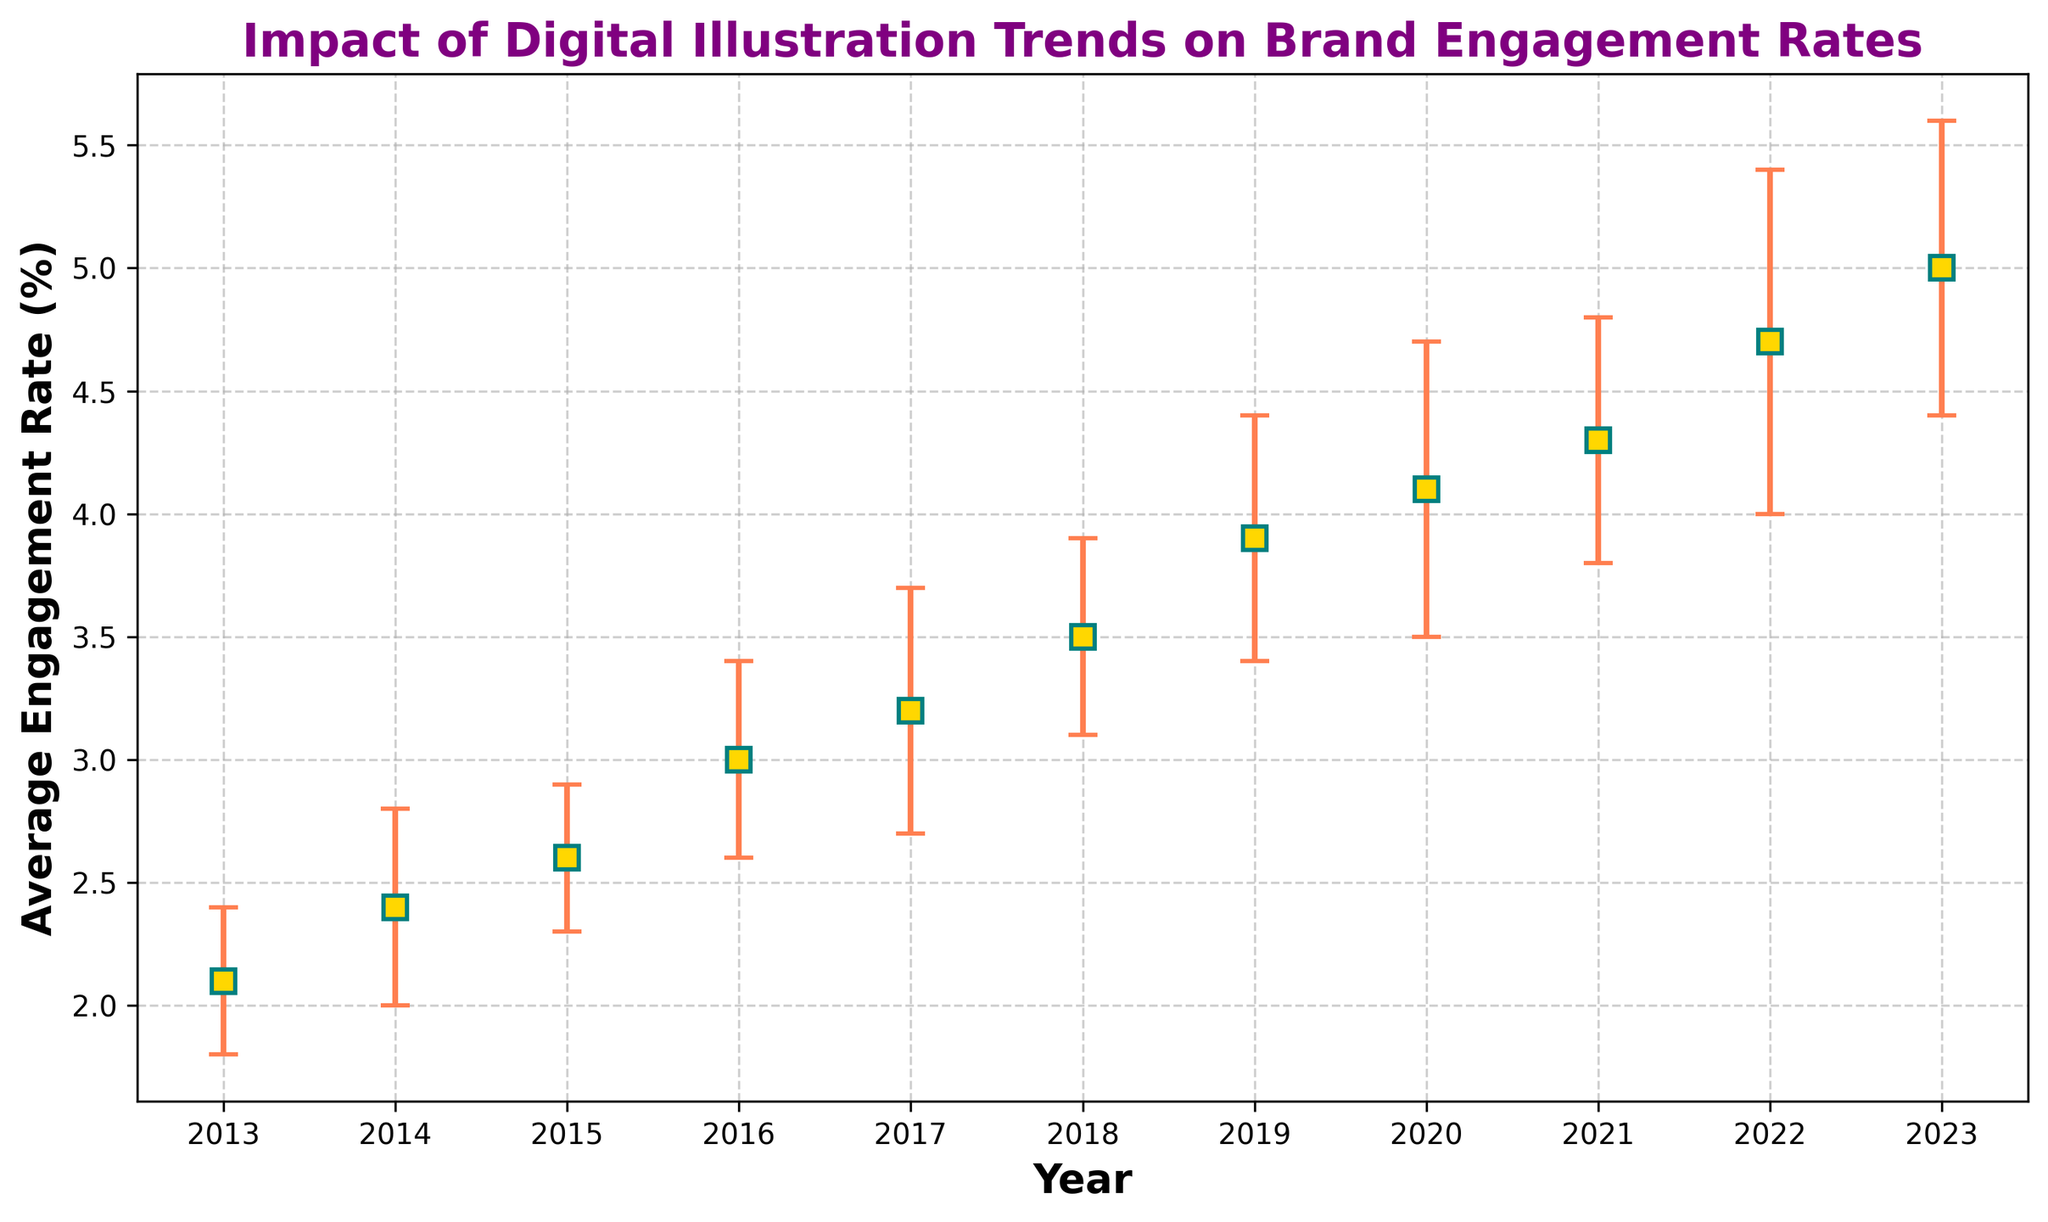what is the average engagement rate for 2020? The figure shows the average engagement rate for 2020 as part of the data set. Locate the data point for the year 2020 and note down the corresponding value.
Answer: 4.1 What is the range of average engagement rates from 2013 to 2023? To find the range, identify the highest and lowest engagement rates within the years 2013 to 2023 from the figure. Subtract the smallest value (2.1% for 2013) from the largest value (5.0% for 2023).
Answer: 2.9 How much did the average engagement rate increase from 2015 to 2023? Locate the average engagement rate for 2015 (2.6) and for 2023 (5.0). Subtract the 2015 value from the 2023 value (5.0 - 2.6).
Answer: 2.4 Which year had the largest error margin in the engagement rate? Check the error bars for each year and identify the one with the longest error bar, which visually represents the largest standard deviation. For 2022, the standard deviation/error margin is the largest at 0.7.
Answer: 2022 What is the trend of the average engagement rates over the period of 2013 to 2023? Observe the trajectory of the engagement rates on the chart from 2013 to 2023. The engagement rates show an upward trend over the years.
Answer: Upward trend Which year had the smallest standard deviation? Compare the length of error bars for each year visually. The year with the shortest error bar indicates the smallest standard deviation. The year 2013 had the smallest standard deviation with 0.3.
Answer: 2013 Did the average engagement rate increase every year between 2013 and 2023? Look at the trend of the average engagement rate data points each year from 2013 to 2023. Verify if each subsequent year shows an increase from the previous year.
Answer: Yes How does the average engagement rate in 2017 compare to the one in 2018? Locate the data points for the years 2017 (3.2) and 2018 (3.5) and compare them to see which one is higher.
Answer: 2018 has a higher rate What is the difference between the highest and lowest engagement rate from 2017 to 2020? Identify the highest (4.1 in 2020) and lowest (3.2 in 2017) engagement rates within the specified years. Subtract the lowest value from the highest value (4.1 - 3.2).
Answer: 0.9 